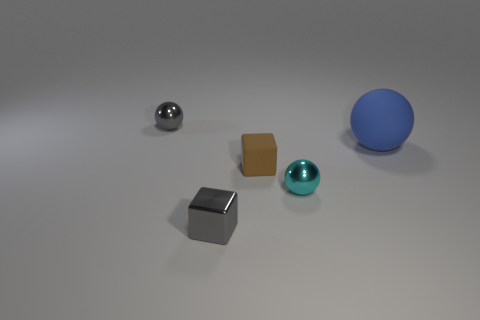How many small objects have the same color as the shiny block?
Your response must be concise. 1. The thing that is right of the small brown cube and to the left of the big matte sphere has what shape?
Make the answer very short. Sphere. Is the number of large blue matte objects greater than the number of small cyan cylinders?
Keep it short and to the point. Yes. What is the large blue sphere made of?
Make the answer very short. Rubber. Are there any other things that have the same size as the gray metallic sphere?
Your response must be concise. Yes. What is the size of the gray shiny thing that is the same shape as the blue thing?
Provide a succinct answer. Small. There is a gray object that is in front of the big blue sphere; are there any tiny metallic objects behind it?
Keep it short and to the point. Yes. Do the tiny rubber block and the matte sphere have the same color?
Provide a succinct answer. No. How many other things are the same shape as the large object?
Offer a terse response. 2. Is the number of blue spheres that are behind the blue rubber ball greater than the number of gray shiny blocks behind the cyan thing?
Your response must be concise. No. 